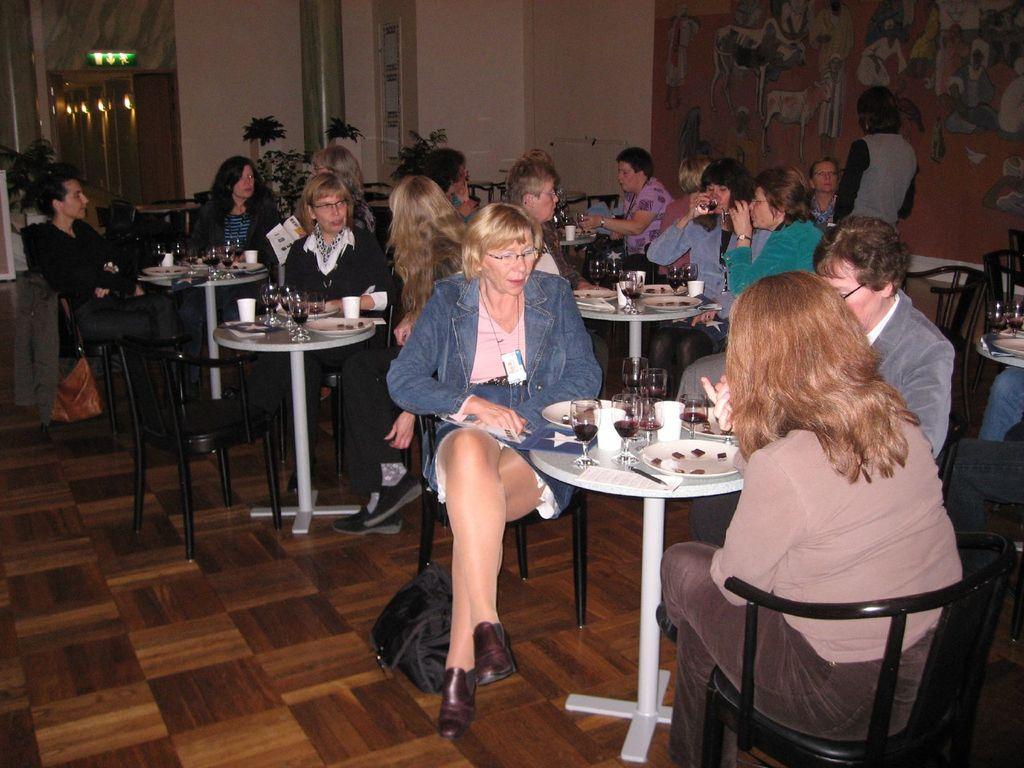How would you summarize this image in a sentence or two? In this image I see lot of people who are sitting on the chairs and there are lot of tables in front and I can also see that there are glasses and plates on the table. In the background few plants and the wall. 